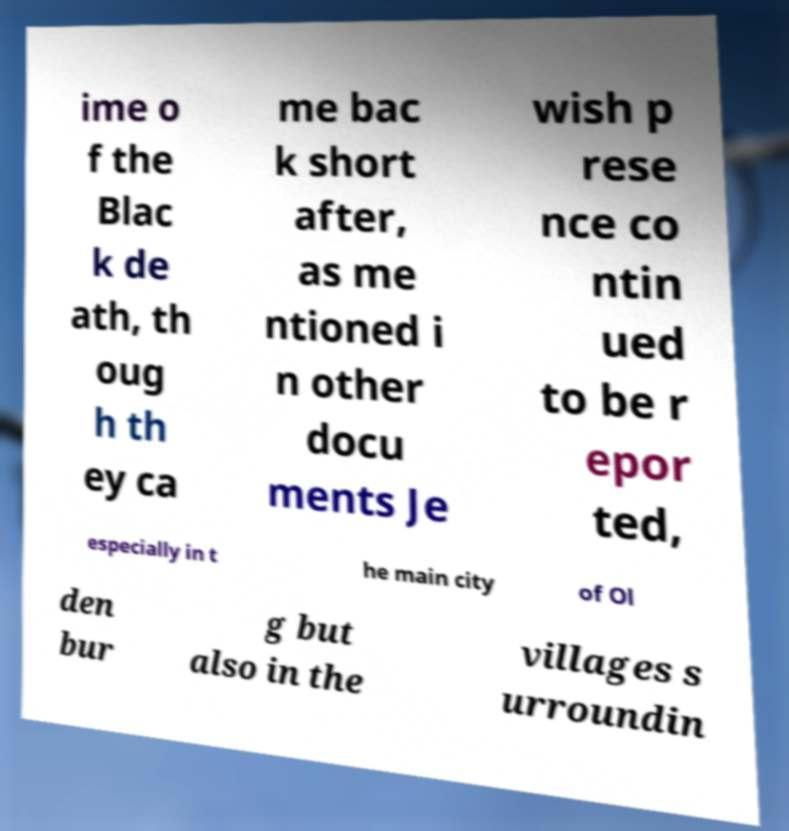There's text embedded in this image that I need extracted. Can you transcribe it verbatim? ime o f the Blac k de ath, th oug h th ey ca me bac k short after, as me ntioned i n other docu ments Je wish p rese nce co ntin ued to be r epor ted, especially in t he main city of Ol den bur g but also in the villages s urroundin 